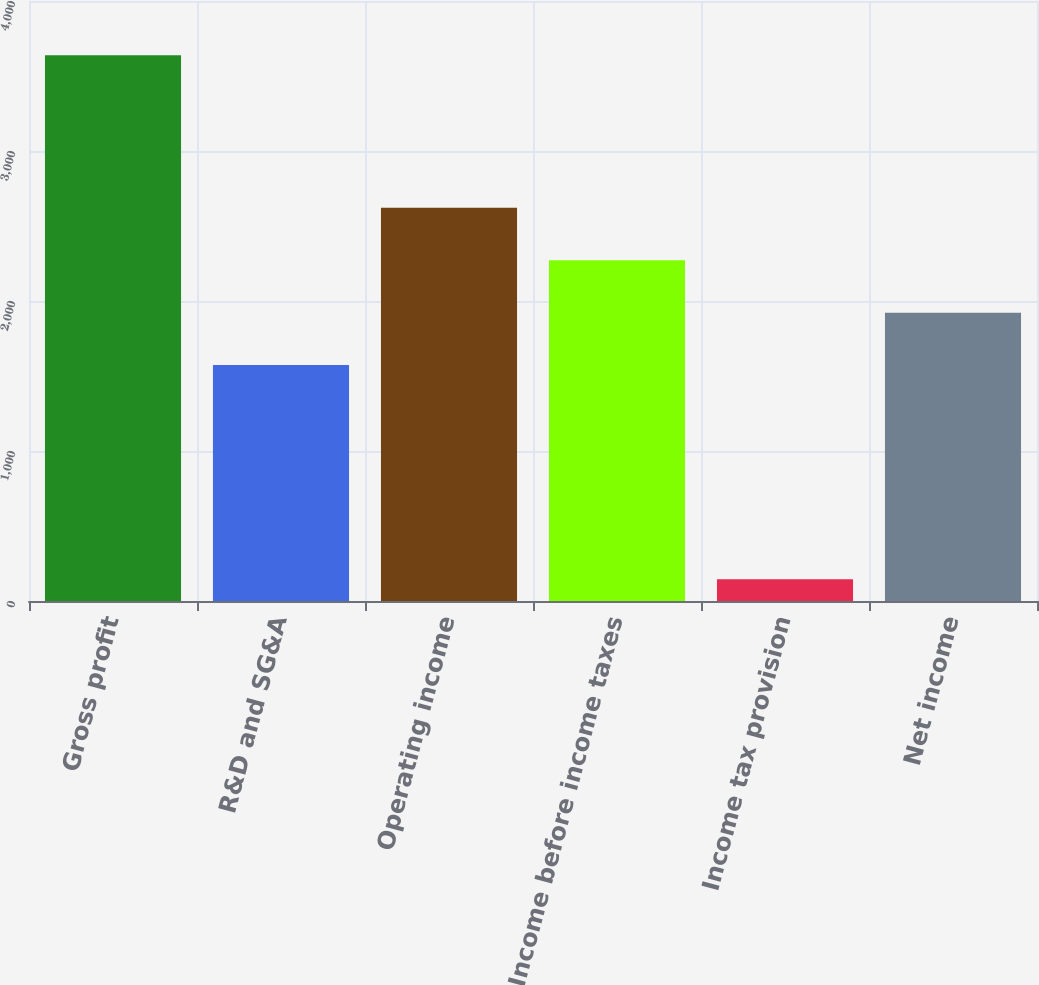Convert chart to OTSL. <chart><loc_0><loc_0><loc_500><loc_500><bar_chart><fcel>Gross profit<fcel>R&D and SG&A<fcel>Operating income<fcel>Income before income taxes<fcel>Income tax provision<fcel>Net income<nl><fcel>3638<fcel>1573<fcel>2620.9<fcel>2271.6<fcel>145<fcel>1922.3<nl></chart> 